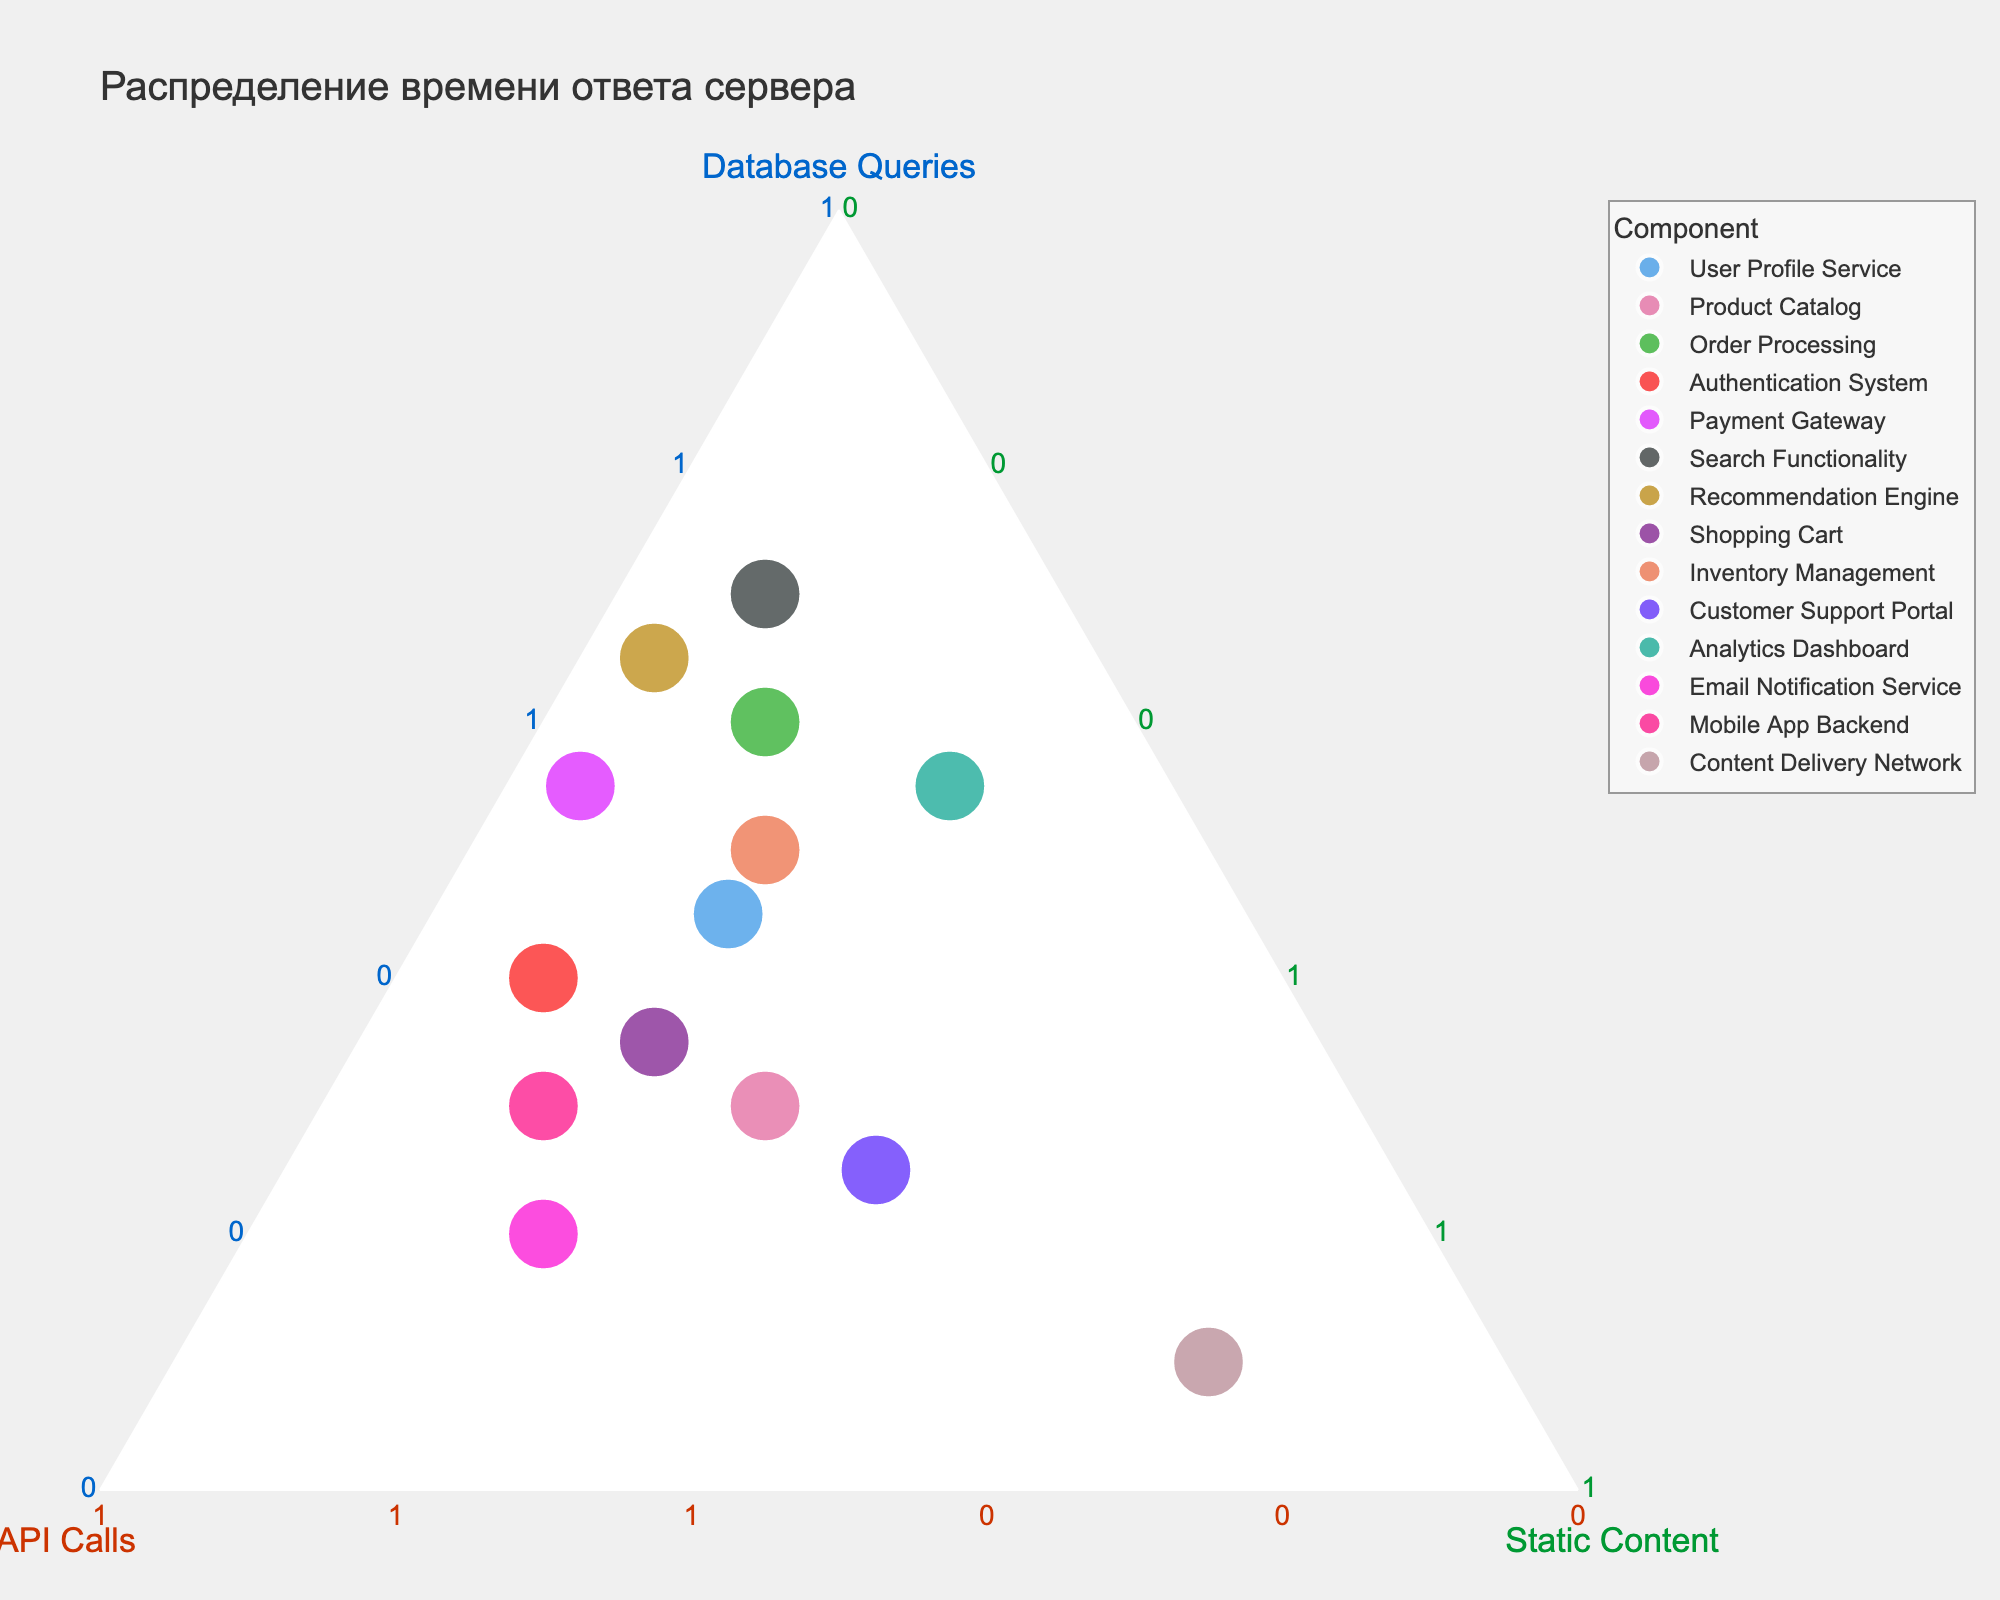What's the main title of the ternary plot? The title is usually displayed at the top of the plot as a text label. In this case, "Распределение времени ответа сервера" is the main title.
Answer: Распределение времени ответа сервера What component has the highest percentage of static content delivery? To determine this, locate the vertex representing static content and find the point closest to it. The component closest to this vertex is "Content Delivery Network" as it is designed specifically for static content.
Answer: Content Delivery Network Which component has the largest total response time proportionally? The size of the markers represents the total response time. Look for the largest marker. This corresponds to the "Search Functionality".
Answer: Search Functionality Compare the proportion of API Calls between "User Profile Service" and "Authentication System". Which one has a higher proportion? Find both components on the plot, then look at their positions relative to the vertex labeled "API Calls". "Authentication System" is closer to the API Calls vertex.
Answer: Authentication System Identify the component where database queries have the highest percentage. Look at the position closest to the database queries vertex. The "Search Functionality" component is closest, indicating the highest percentage of database queries.
Answer: Search Functionality Examine the positions of "Product Catalog" and "Order Processing". Which has a higher percentage of static content? Locate both components and compare their positions relative to the static content vertex. "Product Catalog" is closer to the static content vertex than "Order Processing".
Answer: Product Catalog Which component has an even distribution of the three elements? An even distribution would ideally be near the center of the plot. "Mobile App Backend" and "Product Catalog" are relatively closer to the center compared to other components.
Answer: Mobile App Backend and Product Catalog For the "Recommendation Engine", what's the approximate percentage breakdown among the three elements? Locate "Recommendation Engine" data point and read off the percentages along the three axes.
Answer: Database Queries ~65%, API Calls ~30%, Static Content ~5% Calculate the combined percentage of API Calls and Static Content for the "Email Notification Service". Add the percentage of API Calls (60%) and Static Content (20%) for the "Email Notification Service".
Answer: 80% What component has nearly equal proportions of database queries and static content? Look for components that lie close to the line dividing database queries and static content vertices. "Analytics Dashboard" is near this line, indicating similar proportions.
Answer: Analytics Dashboard 